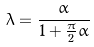Convert formula to latex. <formula><loc_0><loc_0><loc_500><loc_500>\lambda = \frac { \alpha } { 1 + \frac { \pi } { 2 } \alpha }</formula> 